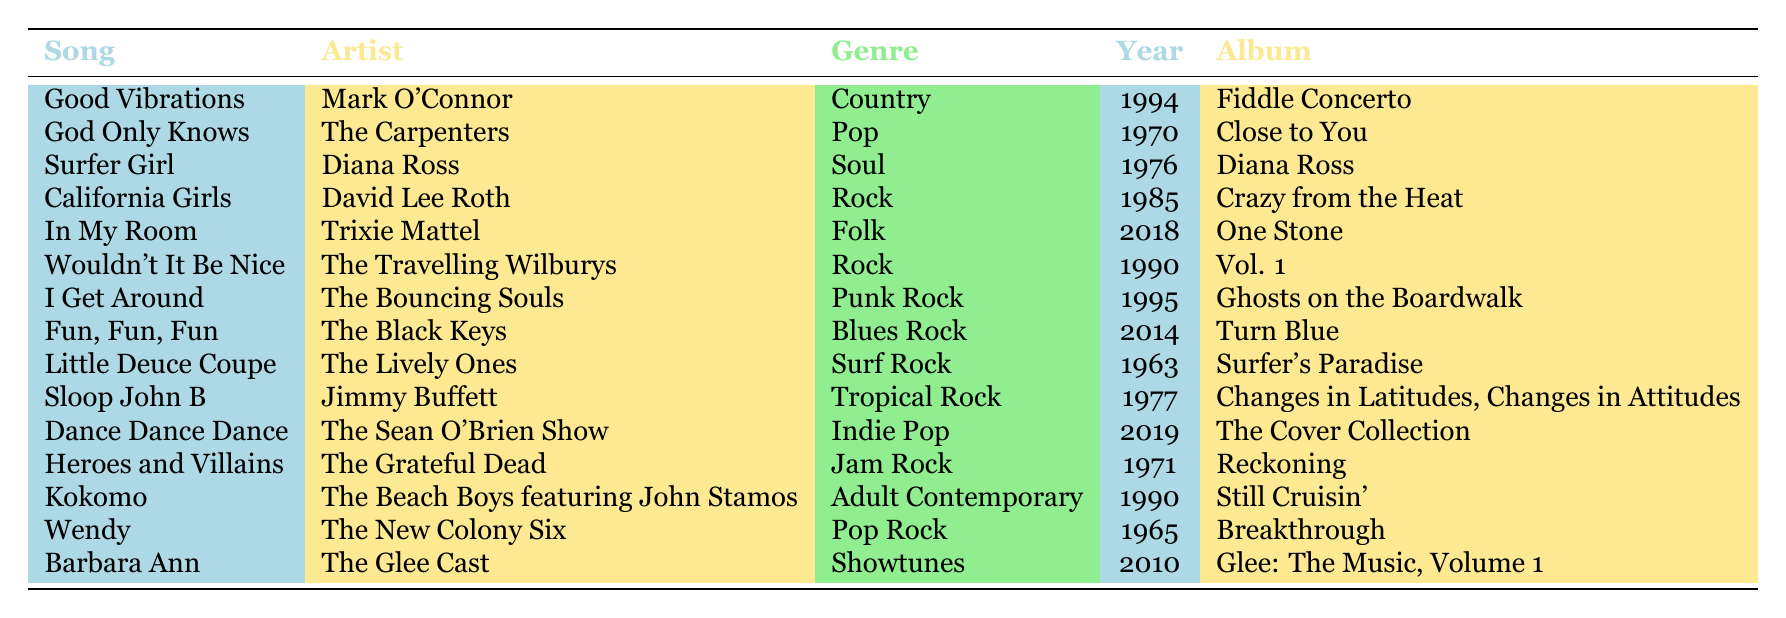What is the genre of "God Only Knows"? According to the table, "God Only Knows" is categorized under the genre "Pop."
Answer: Pop Which artist covered "Surfer Girl"? The table indicates that "Surfer Girl" was covered by Diana Ross.
Answer: Diana Ross How many covers of Beach Boys songs were made in the 1990s? The table lists the covers from the 1990s: "Wouldn't It Be Nice" (1990), "Kokomo" (1990), and "Good Vibrations" (1994). This makes a total of 3 covers.
Answer: 3 Is there a cover of "Fun, Fun, Fun" in the table? Yes, "Fun, Fun, Fun" is covered by The Black Keys according to the table.
Answer: Yes Which genre has the most covers of Beach Boys songs listed in the table? The genres with covers listed are Country, Pop, Soul, Rock, Folk, Punk Rock, Blues Rock, Surf Rock, Tropical Rock, Indie Pop, Jam Rock, Adult Contemporary, Pop Rock, and Showtunes. The table shows two covers in the Rock genre ("California Girls" and "Wouldn't It Be Nice"), which is more than any other genre listed.
Answer: Rock What is the release year of the cover by The Bouncing Souls? The table states that the cover by The Bouncing Souls, "I Get Around," was released in 1995.
Answer: 1995 Which artist performed a cover of "Heroes and Villains"? From the table, The Grateful Dead is the artist that covered "Heroes and Villains."
Answer: The Grateful Dead How many different genres are represented in the table? The table lists 14 unique genres: Country, Pop, Soul, Rock, Folk, Punk Rock, Blues Rock, Surf Rock, Tropical Rock, Indie Pop, Jam Rock, Adult Contemporary, Pop Rock, and Showtunes. In total, there are 14 different genres.
Answer: 14 What is the average release year of the covers listed in the table? To find the average release year, we first identify the years: 1963, 1965, 1970, 1971, 1976, 1977, 1985, 1990 (two covers), 1994, 1995, 2010, 2014, and 2018. There are 13 data points, and the sum of these years is 1963 + 1965 + 1970 + 1971 + 1976 + 1977 + 1985 + 1990 + 1990 + 1994 + 1995 + 2010 + 2014 + 2018 = 23498. Dividing this sum by 13 gives an average of 1815. To simplify, let's divide 23498 by 13, which equals approximately 1815. Thus, the average is around 1991.
Answer: 1991 